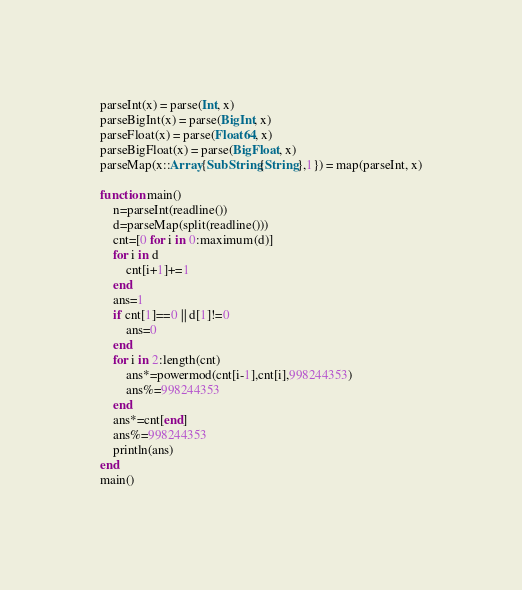<code> <loc_0><loc_0><loc_500><loc_500><_Julia_>parseInt(x) = parse(Int, x)
parseBigInt(x) = parse(BigInt, x)
parseFloat(x) = parse(Float64, x)
parseBigFloat(x) = parse(BigFloat, x)
parseMap(x::Array{SubString{String},1}) = map(parseInt, x)

function main()
    n=parseInt(readline())
    d=parseMap(split(readline()))
    cnt=[0 for i in 0:maximum(d)]
    for i in d
        cnt[i+1]+=1
    end
    ans=1
    if cnt[1]==0 || d[1]!=0
        ans=0
    end
    for i in 2:length(cnt)
        ans*=powermod(cnt[i-1],cnt[i],998244353)
        ans%=998244353
    end
    ans*=cnt[end]
    ans%=998244353
    println(ans)
end
main()</code> 